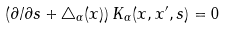Convert formula to latex. <formula><loc_0><loc_0><loc_500><loc_500>\left ( \partial / \partial s + \triangle _ { \alpha } ( x ) \right ) K _ { \alpha } ( x , x ^ { \prime } , s ) = 0</formula> 